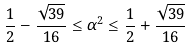<formula> <loc_0><loc_0><loc_500><loc_500>\frac { 1 } { 2 } - \frac { \sqrt { 3 9 } } { 1 6 } \leq \alpha ^ { 2 } \leq \frac { 1 } { 2 } + \frac { \sqrt { 3 9 } } { 1 6 }</formula> 